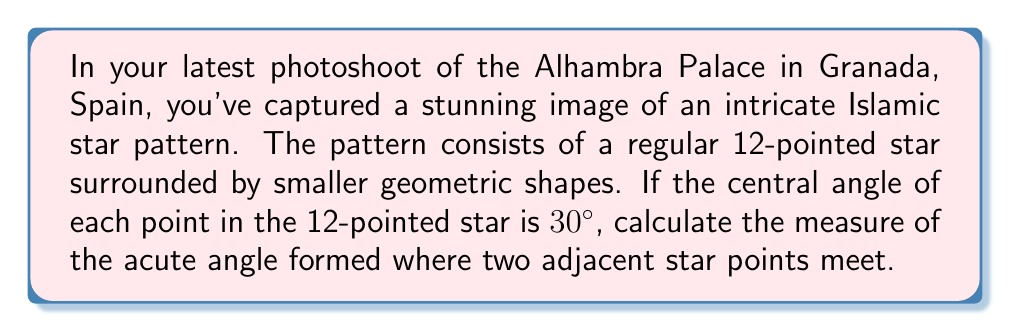What is the answer to this math problem? Let's approach this step-by-step:

1) First, we need to understand the geometry of a regular 12-pointed star:
   - A full circle has 360°
   - The star has 12 points, so each point occupies $\frac{360°}{12} = 30°$ of the circle

2) We're given that the central angle of each point is 30°. This means that each point of the star is an isosceles triangle.

3) Let's consider one of these isosceles triangles:
   - The base angles of this isosceles triangle are equal
   - Let's call the measure of each of these base angles $x$

4) In any triangle, the sum of all angles is 180°. So for our isosceles triangle:

   $$ 30° + x + x = 180° $$
   $$ 30° + 2x = 180° $$

5) Solve for $x$:
   $$ 2x = 180° - 30° = 150° $$
   $$ x = 75° $$

6) Now, the acute angle we're looking for is formed where two of these isosceles triangles meet. It's the sum of two base angles from adjacent triangles:

   $$ \text{Acute angle} = 75° + 75° = 150° $$

7) However, this is the reflex angle (the larger angle). The acute angle we're looking for is the complement of this angle:

   $$ \text{Acute angle} = 360° - 150° = 210° $$

Therefore, the acute angle formed where two adjacent star points meet is 210°.

[asy]
unitsize(100);
pair A=(0,0), B=(1,0), C=rotate(30)*B;
draw(A--B--C--cycle);
draw(A--rotate(60)*B);
draw(A--rotate(90)*B);
draw(A--rotate(120)*B);
draw(A--rotate(150)*B);
draw(A--rotate(180)*B);
label("30°", A, NE);
label("x", B, SE);
label("x", C, SW);
[/asy]
Answer: The measure of the acute angle formed where two adjacent star points meet is 210°. 